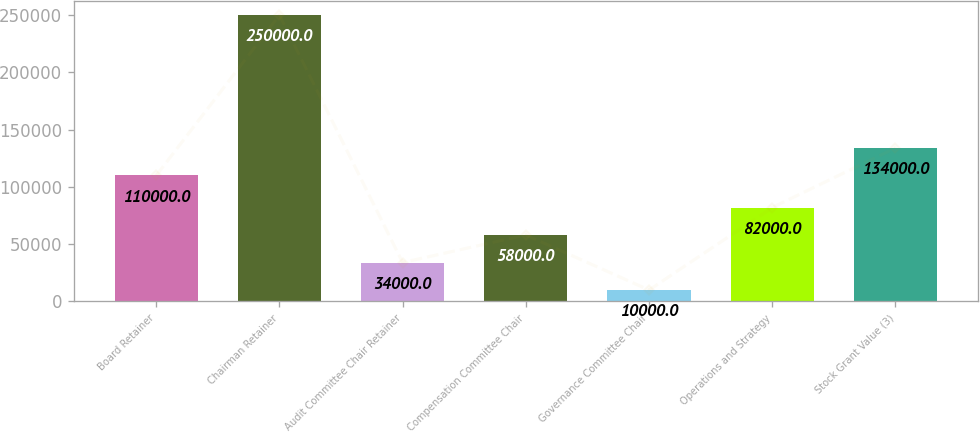<chart> <loc_0><loc_0><loc_500><loc_500><bar_chart><fcel>Board Retainer<fcel>Chairman Retainer<fcel>Audit Committee Chair Retainer<fcel>Compensation Committee Chair<fcel>Governance Committee Chair<fcel>Operations and Strategy<fcel>Stock Grant Value (3)<nl><fcel>110000<fcel>250000<fcel>34000<fcel>58000<fcel>10000<fcel>82000<fcel>134000<nl></chart> 